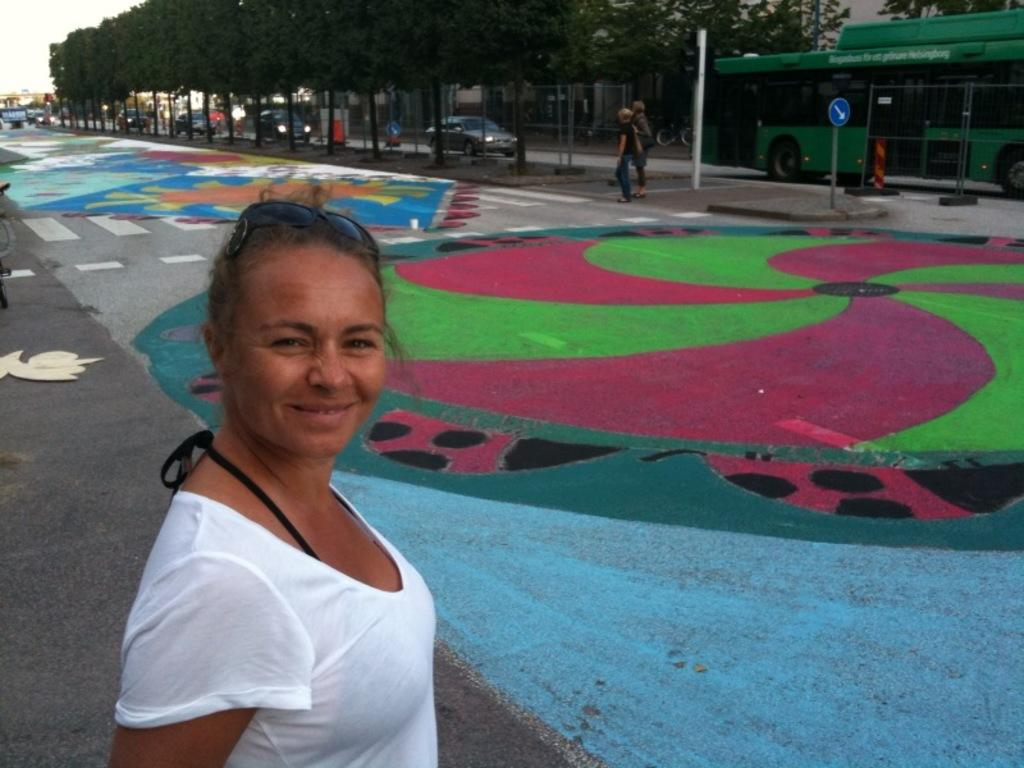Who is the main subject in the image? There is a woman in the image. What is the woman doing in the image? The woman is posing for a camera. What is the woman's facial expression in the image? The woman is smiling. What can be seen in the background of the image? There are trees, vehicles, poles, boards, and the sky visible in the background of the image. Are there any other people present in the image? Yes, there are people in the background of the image. What color of paint is being used on the woman's legs in the image? There is no paint or reference to the woman's legs in the image. What type of mint is growing near the trees in the background of the image? There is no mint or indication of any plants growing near the trees in the image. 